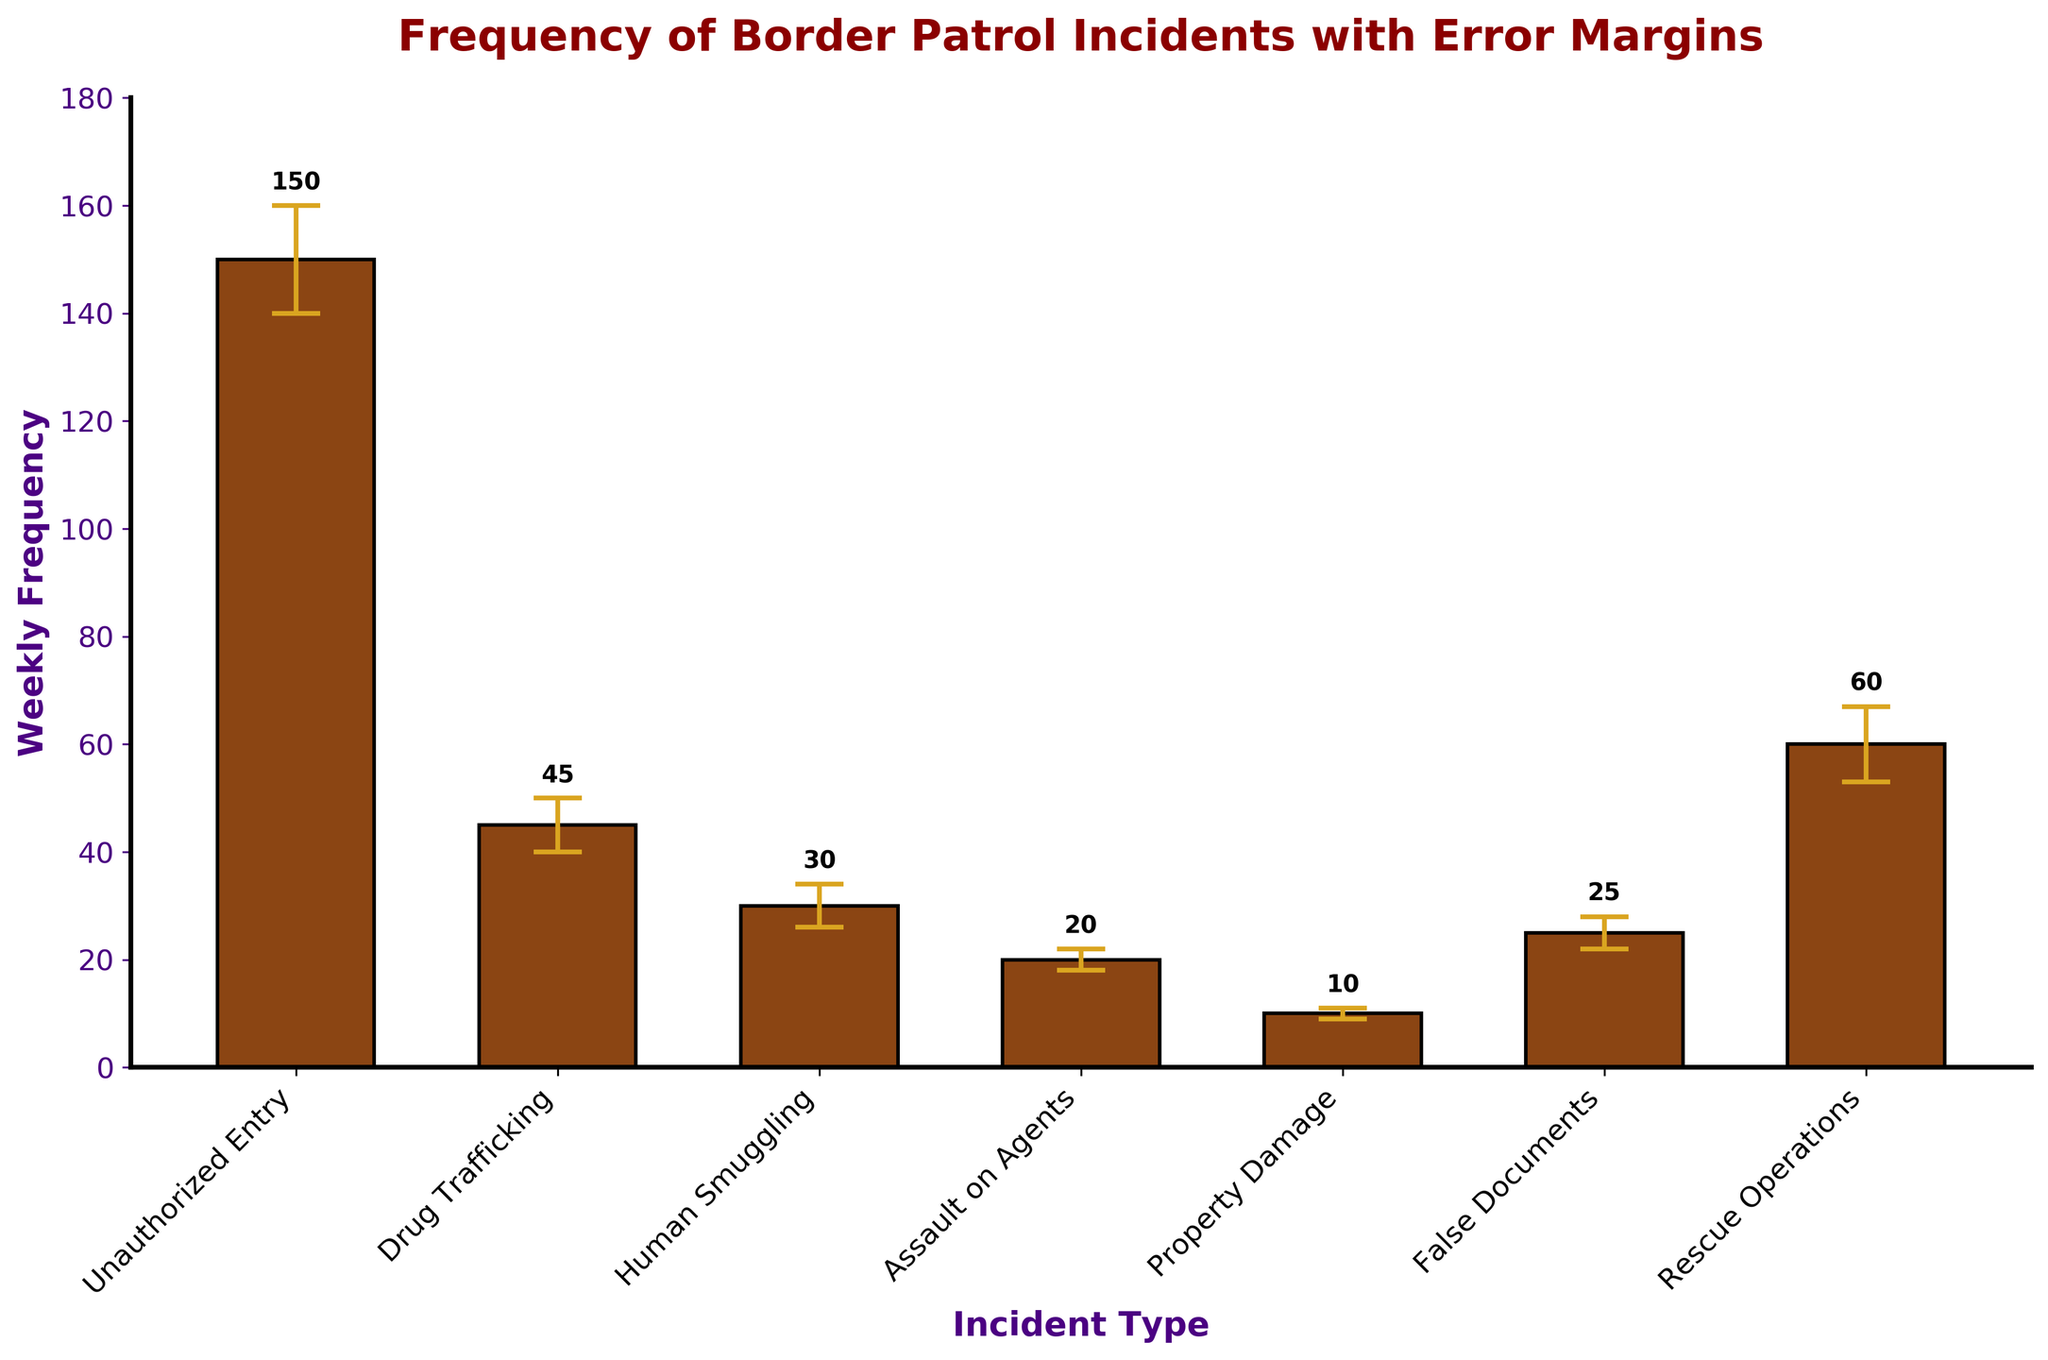What's the title of the figure? The title of the figure is placed at the top and it is written in a large, bold font. It states the key insight or purpose of the visualization.
Answer: Frequency of Border Patrol Incidents with Error Margins Which incident type has the highest weekly frequency? By examining the heights of the bars in the bar chart, the tallest bar corresponds to the incident type with the highest frequency.
Answer: Unauthorized Entry What is the significance of the vertical lines with horizontal caps on the bars? These lines represent error margins, which indicate the variability or uncertainty in the weekly frequency data, providing a range within which the true value likely falls.
Answer: Error margins How many incident types have a weekly frequency greater than 25? By looking at the height of the bars and their respective labels, we can count the bars that surpass the 25 mark on the y-axis.
Answer: 4 (Unauthorized Entry, Drug Trafficking, Rescue Operations, False Documents) What is the weekly frequency of False Documents incidents? By identifying the bar labeled as False Documents and reading its height, you can determine its weekly frequency.
Answer: 25 Which incident type has the smallest error margin? The error margins are indicated by the vertical lines with horizontal caps on each bar. By comparing these, you determine which one is the shortest.
Answer: Property Damage Which incident type has a larger error margin: Human Smuggling or Assault on Agents? Compare the length of the error bars (vertical lines) with horizontal caps for Human Smuggling and Assault on Agents.
Answer: Human Smuggling Is the error margin of Rescue Operations higher than that of Drug Trafficking? Compare the lengths of the error bars (vertical lines with horizontal caps) for Rescue Operations and Drug Trafficking.
Answer: Yes 